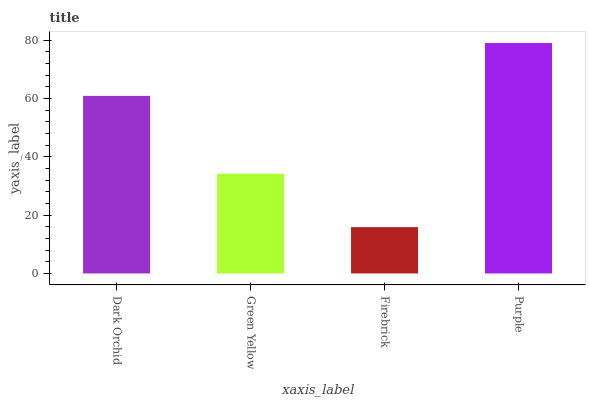Is Firebrick the minimum?
Answer yes or no. Yes. Is Purple the maximum?
Answer yes or no. Yes. Is Green Yellow the minimum?
Answer yes or no. No. Is Green Yellow the maximum?
Answer yes or no. No. Is Dark Orchid greater than Green Yellow?
Answer yes or no. Yes. Is Green Yellow less than Dark Orchid?
Answer yes or no. Yes. Is Green Yellow greater than Dark Orchid?
Answer yes or no. No. Is Dark Orchid less than Green Yellow?
Answer yes or no. No. Is Dark Orchid the high median?
Answer yes or no. Yes. Is Green Yellow the low median?
Answer yes or no. Yes. Is Green Yellow the high median?
Answer yes or no. No. Is Firebrick the low median?
Answer yes or no. No. 